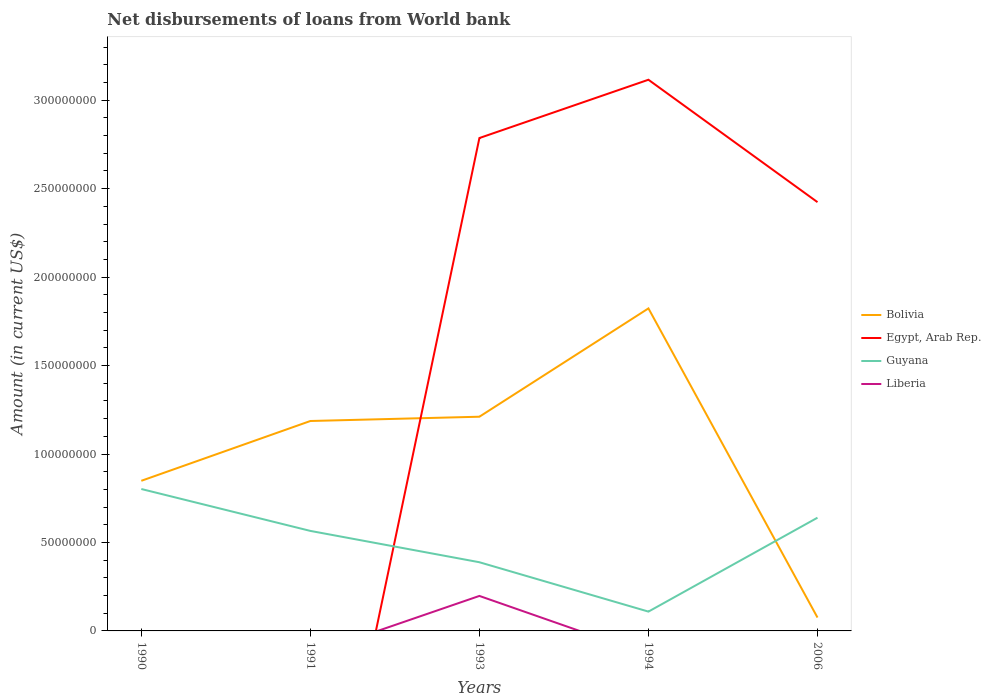Does the line corresponding to Bolivia intersect with the line corresponding to Guyana?
Make the answer very short. Yes. What is the total amount of loan disbursed from World Bank in Guyana in the graph?
Provide a succinct answer. -7.46e+06. What is the difference between the highest and the second highest amount of loan disbursed from World Bank in Bolivia?
Give a very brief answer. 1.75e+08. What is the difference between the highest and the lowest amount of loan disbursed from World Bank in Egypt, Arab Rep.?
Give a very brief answer. 3. How many lines are there?
Offer a terse response. 4. How many years are there in the graph?
Provide a succinct answer. 5. What is the difference between two consecutive major ticks on the Y-axis?
Provide a succinct answer. 5.00e+07. Are the values on the major ticks of Y-axis written in scientific E-notation?
Give a very brief answer. No. Where does the legend appear in the graph?
Give a very brief answer. Center right. How many legend labels are there?
Your answer should be compact. 4. How are the legend labels stacked?
Provide a succinct answer. Vertical. What is the title of the graph?
Provide a short and direct response. Net disbursements of loans from World bank. Does "Kiribati" appear as one of the legend labels in the graph?
Give a very brief answer. No. What is the label or title of the X-axis?
Your response must be concise. Years. What is the Amount (in current US$) in Bolivia in 1990?
Provide a short and direct response. 8.49e+07. What is the Amount (in current US$) in Egypt, Arab Rep. in 1990?
Keep it short and to the point. 0. What is the Amount (in current US$) in Guyana in 1990?
Offer a very short reply. 8.02e+07. What is the Amount (in current US$) in Liberia in 1990?
Provide a short and direct response. 0. What is the Amount (in current US$) of Bolivia in 1991?
Provide a short and direct response. 1.19e+08. What is the Amount (in current US$) in Guyana in 1991?
Your response must be concise. 5.65e+07. What is the Amount (in current US$) in Bolivia in 1993?
Your answer should be very brief. 1.21e+08. What is the Amount (in current US$) of Egypt, Arab Rep. in 1993?
Your response must be concise. 2.79e+08. What is the Amount (in current US$) of Guyana in 1993?
Your response must be concise. 3.88e+07. What is the Amount (in current US$) in Liberia in 1993?
Make the answer very short. 1.98e+07. What is the Amount (in current US$) of Bolivia in 1994?
Make the answer very short. 1.82e+08. What is the Amount (in current US$) in Egypt, Arab Rep. in 1994?
Your response must be concise. 3.12e+08. What is the Amount (in current US$) of Guyana in 1994?
Provide a short and direct response. 1.09e+07. What is the Amount (in current US$) of Bolivia in 2006?
Make the answer very short. 7.56e+06. What is the Amount (in current US$) in Egypt, Arab Rep. in 2006?
Ensure brevity in your answer.  2.42e+08. What is the Amount (in current US$) in Guyana in 2006?
Offer a terse response. 6.40e+07. What is the Amount (in current US$) of Liberia in 2006?
Provide a succinct answer. 0. Across all years, what is the maximum Amount (in current US$) of Bolivia?
Provide a succinct answer. 1.82e+08. Across all years, what is the maximum Amount (in current US$) in Egypt, Arab Rep.?
Your answer should be very brief. 3.12e+08. Across all years, what is the maximum Amount (in current US$) of Guyana?
Keep it short and to the point. 8.02e+07. Across all years, what is the maximum Amount (in current US$) in Liberia?
Your answer should be very brief. 1.98e+07. Across all years, what is the minimum Amount (in current US$) in Bolivia?
Offer a terse response. 7.56e+06. Across all years, what is the minimum Amount (in current US$) in Egypt, Arab Rep.?
Keep it short and to the point. 0. Across all years, what is the minimum Amount (in current US$) of Guyana?
Provide a succinct answer. 1.09e+07. Across all years, what is the minimum Amount (in current US$) in Liberia?
Offer a very short reply. 0. What is the total Amount (in current US$) in Bolivia in the graph?
Keep it short and to the point. 5.14e+08. What is the total Amount (in current US$) of Egypt, Arab Rep. in the graph?
Provide a succinct answer. 8.32e+08. What is the total Amount (in current US$) of Guyana in the graph?
Your answer should be compact. 2.50e+08. What is the total Amount (in current US$) of Liberia in the graph?
Make the answer very short. 1.98e+07. What is the difference between the Amount (in current US$) in Bolivia in 1990 and that in 1991?
Give a very brief answer. -3.38e+07. What is the difference between the Amount (in current US$) of Guyana in 1990 and that in 1991?
Your response must be concise. 2.37e+07. What is the difference between the Amount (in current US$) of Bolivia in 1990 and that in 1993?
Your answer should be very brief. -3.62e+07. What is the difference between the Amount (in current US$) in Guyana in 1990 and that in 1993?
Give a very brief answer. 4.14e+07. What is the difference between the Amount (in current US$) of Bolivia in 1990 and that in 1994?
Give a very brief answer. -9.74e+07. What is the difference between the Amount (in current US$) in Guyana in 1990 and that in 1994?
Make the answer very short. 6.93e+07. What is the difference between the Amount (in current US$) in Bolivia in 1990 and that in 2006?
Ensure brevity in your answer.  7.73e+07. What is the difference between the Amount (in current US$) of Guyana in 1990 and that in 2006?
Offer a very short reply. 1.62e+07. What is the difference between the Amount (in current US$) in Bolivia in 1991 and that in 1993?
Provide a succinct answer. -2.42e+06. What is the difference between the Amount (in current US$) of Guyana in 1991 and that in 1993?
Make the answer very short. 1.77e+07. What is the difference between the Amount (in current US$) in Bolivia in 1991 and that in 1994?
Make the answer very short. -6.36e+07. What is the difference between the Amount (in current US$) of Guyana in 1991 and that in 1994?
Keep it short and to the point. 4.56e+07. What is the difference between the Amount (in current US$) in Bolivia in 1991 and that in 2006?
Provide a succinct answer. 1.11e+08. What is the difference between the Amount (in current US$) in Guyana in 1991 and that in 2006?
Give a very brief answer. -7.46e+06. What is the difference between the Amount (in current US$) in Bolivia in 1993 and that in 1994?
Provide a succinct answer. -6.12e+07. What is the difference between the Amount (in current US$) of Egypt, Arab Rep. in 1993 and that in 1994?
Provide a succinct answer. -3.30e+07. What is the difference between the Amount (in current US$) of Guyana in 1993 and that in 1994?
Your answer should be very brief. 2.79e+07. What is the difference between the Amount (in current US$) in Bolivia in 1993 and that in 2006?
Your answer should be very brief. 1.14e+08. What is the difference between the Amount (in current US$) of Egypt, Arab Rep. in 1993 and that in 2006?
Give a very brief answer. 3.62e+07. What is the difference between the Amount (in current US$) of Guyana in 1993 and that in 2006?
Provide a short and direct response. -2.52e+07. What is the difference between the Amount (in current US$) of Bolivia in 1994 and that in 2006?
Give a very brief answer. 1.75e+08. What is the difference between the Amount (in current US$) of Egypt, Arab Rep. in 1994 and that in 2006?
Your answer should be very brief. 6.92e+07. What is the difference between the Amount (in current US$) in Guyana in 1994 and that in 2006?
Your response must be concise. -5.31e+07. What is the difference between the Amount (in current US$) in Bolivia in 1990 and the Amount (in current US$) in Guyana in 1991?
Ensure brevity in your answer.  2.83e+07. What is the difference between the Amount (in current US$) in Bolivia in 1990 and the Amount (in current US$) in Egypt, Arab Rep. in 1993?
Your response must be concise. -1.94e+08. What is the difference between the Amount (in current US$) of Bolivia in 1990 and the Amount (in current US$) of Guyana in 1993?
Ensure brevity in your answer.  4.60e+07. What is the difference between the Amount (in current US$) in Bolivia in 1990 and the Amount (in current US$) in Liberia in 1993?
Ensure brevity in your answer.  6.51e+07. What is the difference between the Amount (in current US$) in Guyana in 1990 and the Amount (in current US$) in Liberia in 1993?
Give a very brief answer. 6.04e+07. What is the difference between the Amount (in current US$) of Bolivia in 1990 and the Amount (in current US$) of Egypt, Arab Rep. in 1994?
Make the answer very short. -2.27e+08. What is the difference between the Amount (in current US$) of Bolivia in 1990 and the Amount (in current US$) of Guyana in 1994?
Offer a terse response. 7.39e+07. What is the difference between the Amount (in current US$) of Bolivia in 1990 and the Amount (in current US$) of Egypt, Arab Rep. in 2006?
Make the answer very short. -1.58e+08. What is the difference between the Amount (in current US$) in Bolivia in 1990 and the Amount (in current US$) in Guyana in 2006?
Your answer should be compact. 2.09e+07. What is the difference between the Amount (in current US$) of Bolivia in 1991 and the Amount (in current US$) of Egypt, Arab Rep. in 1993?
Provide a succinct answer. -1.60e+08. What is the difference between the Amount (in current US$) of Bolivia in 1991 and the Amount (in current US$) of Guyana in 1993?
Provide a succinct answer. 7.98e+07. What is the difference between the Amount (in current US$) of Bolivia in 1991 and the Amount (in current US$) of Liberia in 1993?
Make the answer very short. 9.89e+07. What is the difference between the Amount (in current US$) of Guyana in 1991 and the Amount (in current US$) of Liberia in 1993?
Give a very brief answer. 3.68e+07. What is the difference between the Amount (in current US$) in Bolivia in 1991 and the Amount (in current US$) in Egypt, Arab Rep. in 1994?
Your response must be concise. -1.93e+08. What is the difference between the Amount (in current US$) in Bolivia in 1991 and the Amount (in current US$) in Guyana in 1994?
Your response must be concise. 1.08e+08. What is the difference between the Amount (in current US$) in Bolivia in 1991 and the Amount (in current US$) in Egypt, Arab Rep. in 2006?
Provide a succinct answer. -1.24e+08. What is the difference between the Amount (in current US$) of Bolivia in 1991 and the Amount (in current US$) of Guyana in 2006?
Offer a terse response. 5.47e+07. What is the difference between the Amount (in current US$) of Bolivia in 1993 and the Amount (in current US$) of Egypt, Arab Rep. in 1994?
Ensure brevity in your answer.  -1.90e+08. What is the difference between the Amount (in current US$) of Bolivia in 1993 and the Amount (in current US$) of Guyana in 1994?
Your answer should be compact. 1.10e+08. What is the difference between the Amount (in current US$) of Egypt, Arab Rep. in 1993 and the Amount (in current US$) of Guyana in 1994?
Give a very brief answer. 2.68e+08. What is the difference between the Amount (in current US$) in Bolivia in 1993 and the Amount (in current US$) in Egypt, Arab Rep. in 2006?
Your answer should be compact. -1.21e+08. What is the difference between the Amount (in current US$) in Bolivia in 1993 and the Amount (in current US$) in Guyana in 2006?
Offer a terse response. 5.71e+07. What is the difference between the Amount (in current US$) in Egypt, Arab Rep. in 1993 and the Amount (in current US$) in Guyana in 2006?
Ensure brevity in your answer.  2.15e+08. What is the difference between the Amount (in current US$) in Bolivia in 1994 and the Amount (in current US$) in Egypt, Arab Rep. in 2006?
Provide a short and direct response. -6.01e+07. What is the difference between the Amount (in current US$) of Bolivia in 1994 and the Amount (in current US$) of Guyana in 2006?
Give a very brief answer. 1.18e+08. What is the difference between the Amount (in current US$) of Egypt, Arab Rep. in 1994 and the Amount (in current US$) of Guyana in 2006?
Make the answer very short. 2.48e+08. What is the average Amount (in current US$) of Bolivia per year?
Give a very brief answer. 1.03e+08. What is the average Amount (in current US$) of Egypt, Arab Rep. per year?
Make the answer very short. 1.66e+08. What is the average Amount (in current US$) in Guyana per year?
Your answer should be compact. 5.01e+07. What is the average Amount (in current US$) in Liberia per year?
Provide a short and direct response. 3.96e+06. In the year 1990, what is the difference between the Amount (in current US$) in Bolivia and Amount (in current US$) in Guyana?
Offer a terse response. 4.63e+06. In the year 1991, what is the difference between the Amount (in current US$) of Bolivia and Amount (in current US$) of Guyana?
Provide a short and direct response. 6.21e+07. In the year 1993, what is the difference between the Amount (in current US$) of Bolivia and Amount (in current US$) of Egypt, Arab Rep.?
Your answer should be very brief. -1.58e+08. In the year 1993, what is the difference between the Amount (in current US$) in Bolivia and Amount (in current US$) in Guyana?
Your response must be concise. 8.23e+07. In the year 1993, what is the difference between the Amount (in current US$) of Bolivia and Amount (in current US$) of Liberia?
Make the answer very short. 1.01e+08. In the year 1993, what is the difference between the Amount (in current US$) in Egypt, Arab Rep. and Amount (in current US$) in Guyana?
Make the answer very short. 2.40e+08. In the year 1993, what is the difference between the Amount (in current US$) of Egypt, Arab Rep. and Amount (in current US$) of Liberia?
Offer a very short reply. 2.59e+08. In the year 1993, what is the difference between the Amount (in current US$) in Guyana and Amount (in current US$) in Liberia?
Your response must be concise. 1.90e+07. In the year 1994, what is the difference between the Amount (in current US$) in Bolivia and Amount (in current US$) in Egypt, Arab Rep.?
Provide a short and direct response. -1.29e+08. In the year 1994, what is the difference between the Amount (in current US$) of Bolivia and Amount (in current US$) of Guyana?
Provide a short and direct response. 1.71e+08. In the year 1994, what is the difference between the Amount (in current US$) in Egypt, Arab Rep. and Amount (in current US$) in Guyana?
Offer a terse response. 3.01e+08. In the year 2006, what is the difference between the Amount (in current US$) in Bolivia and Amount (in current US$) in Egypt, Arab Rep.?
Provide a short and direct response. -2.35e+08. In the year 2006, what is the difference between the Amount (in current US$) of Bolivia and Amount (in current US$) of Guyana?
Offer a very short reply. -5.64e+07. In the year 2006, what is the difference between the Amount (in current US$) of Egypt, Arab Rep. and Amount (in current US$) of Guyana?
Keep it short and to the point. 1.78e+08. What is the ratio of the Amount (in current US$) in Bolivia in 1990 to that in 1991?
Keep it short and to the point. 0.72. What is the ratio of the Amount (in current US$) in Guyana in 1990 to that in 1991?
Offer a very short reply. 1.42. What is the ratio of the Amount (in current US$) of Bolivia in 1990 to that in 1993?
Give a very brief answer. 0.7. What is the ratio of the Amount (in current US$) of Guyana in 1990 to that in 1993?
Give a very brief answer. 2.07. What is the ratio of the Amount (in current US$) in Bolivia in 1990 to that in 1994?
Your answer should be very brief. 0.47. What is the ratio of the Amount (in current US$) of Guyana in 1990 to that in 1994?
Offer a very short reply. 7.35. What is the ratio of the Amount (in current US$) in Bolivia in 1990 to that in 2006?
Your response must be concise. 11.22. What is the ratio of the Amount (in current US$) in Guyana in 1990 to that in 2006?
Provide a short and direct response. 1.25. What is the ratio of the Amount (in current US$) in Bolivia in 1991 to that in 1993?
Give a very brief answer. 0.98. What is the ratio of the Amount (in current US$) in Guyana in 1991 to that in 1993?
Offer a very short reply. 1.46. What is the ratio of the Amount (in current US$) of Bolivia in 1991 to that in 1994?
Provide a short and direct response. 0.65. What is the ratio of the Amount (in current US$) in Guyana in 1991 to that in 1994?
Your response must be concise. 5.18. What is the ratio of the Amount (in current US$) in Bolivia in 1991 to that in 2006?
Your answer should be compact. 15.69. What is the ratio of the Amount (in current US$) in Guyana in 1991 to that in 2006?
Provide a succinct answer. 0.88. What is the ratio of the Amount (in current US$) in Bolivia in 1993 to that in 1994?
Your answer should be compact. 0.66. What is the ratio of the Amount (in current US$) in Egypt, Arab Rep. in 1993 to that in 1994?
Your response must be concise. 0.89. What is the ratio of the Amount (in current US$) of Guyana in 1993 to that in 1994?
Give a very brief answer. 3.56. What is the ratio of the Amount (in current US$) in Bolivia in 1993 to that in 2006?
Give a very brief answer. 16.01. What is the ratio of the Amount (in current US$) of Egypt, Arab Rep. in 1993 to that in 2006?
Ensure brevity in your answer.  1.15. What is the ratio of the Amount (in current US$) of Guyana in 1993 to that in 2006?
Make the answer very short. 0.61. What is the ratio of the Amount (in current US$) of Bolivia in 1994 to that in 2006?
Your response must be concise. 24.1. What is the ratio of the Amount (in current US$) of Egypt, Arab Rep. in 1994 to that in 2006?
Your answer should be compact. 1.29. What is the ratio of the Amount (in current US$) in Guyana in 1994 to that in 2006?
Make the answer very short. 0.17. What is the difference between the highest and the second highest Amount (in current US$) in Bolivia?
Offer a very short reply. 6.12e+07. What is the difference between the highest and the second highest Amount (in current US$) of Egypt, Arab Rep.?
Your response must be concise. 3.30e+07. What is the difference between the highest and the second highest Amount (in current US$) in Guyana?
Make the answer very short. 1.62e+07. What is the difference between the highest and the lowest Amount (in current US$) in Bolivia?
Provide a short and direct response. 1.75e+08. What is the difference between the highest and the lowest Amount (in current US$) in Egypt, Arab Rep.?
Offer a terse response. 3.12e+08. What is the difference between the highest and the lowest Amount (in current US$) in Guyana?
Your answer should be compact. 6.93e+07. What is the difference between the highest and the lowest Amount (in current US$) in Liberia?
Give a very brief answer. 1.98e+07. 